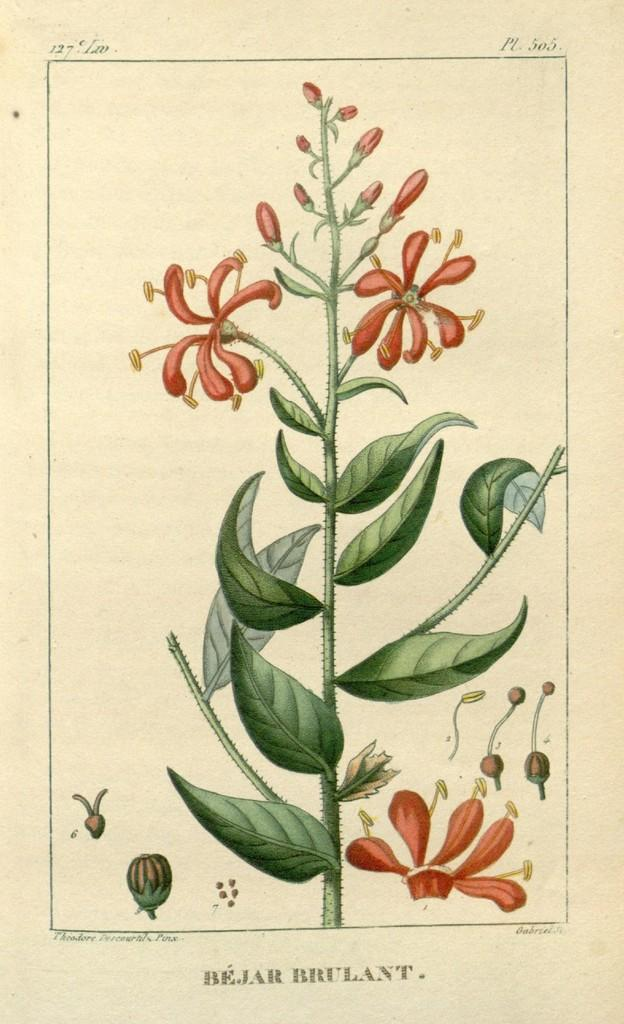What is depicted on the paper in the image? The paper contains a painting of a flower plant. What else can be seen on the paper besides the painting? There is text visible on the paper. How does the water flow around the flower plant in the image? There is no water present in the image; it is a painting of a flower plant on a paper. 